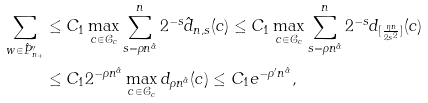<formula> <loc_0><loc_0><loc_500><loc_500>\sum _ { w \in \hat { P } _ { n _ { + } } ^ { \prime \prime } } & \leq C _ { 1 } \max _ { c \in \mathcal { C } _ { c } } \sum _ { s = \rho n ^ { \hat { \alpha } } } ^ { n } 2 ^ { - s } \hat { d } _ { n , s } ( c ) \leq C _ { 1 } \max _ { c \in \mathcal { C } _ { c } } \sum _ { s = \rho n ^ { \hat { \alpha } } } ^ { n } 2 ^ { - s } d _ { [ \frac { \eta n } { 2 s ^ { 2 } } ] } ( c ) \\ & \leq C _ { 1 } 2 ^ { - \rho n ^ { \hat { \alpha } } } \max _ { c \in \mathcal { C } _ { c } } d _ { \rho n ^ { \hat { \alpha } } } ( c ) \leq C _ { 1 } e ^ { - \rho ^ { \prime } n ^ { \hat { \alpha } } } ,</formula> 